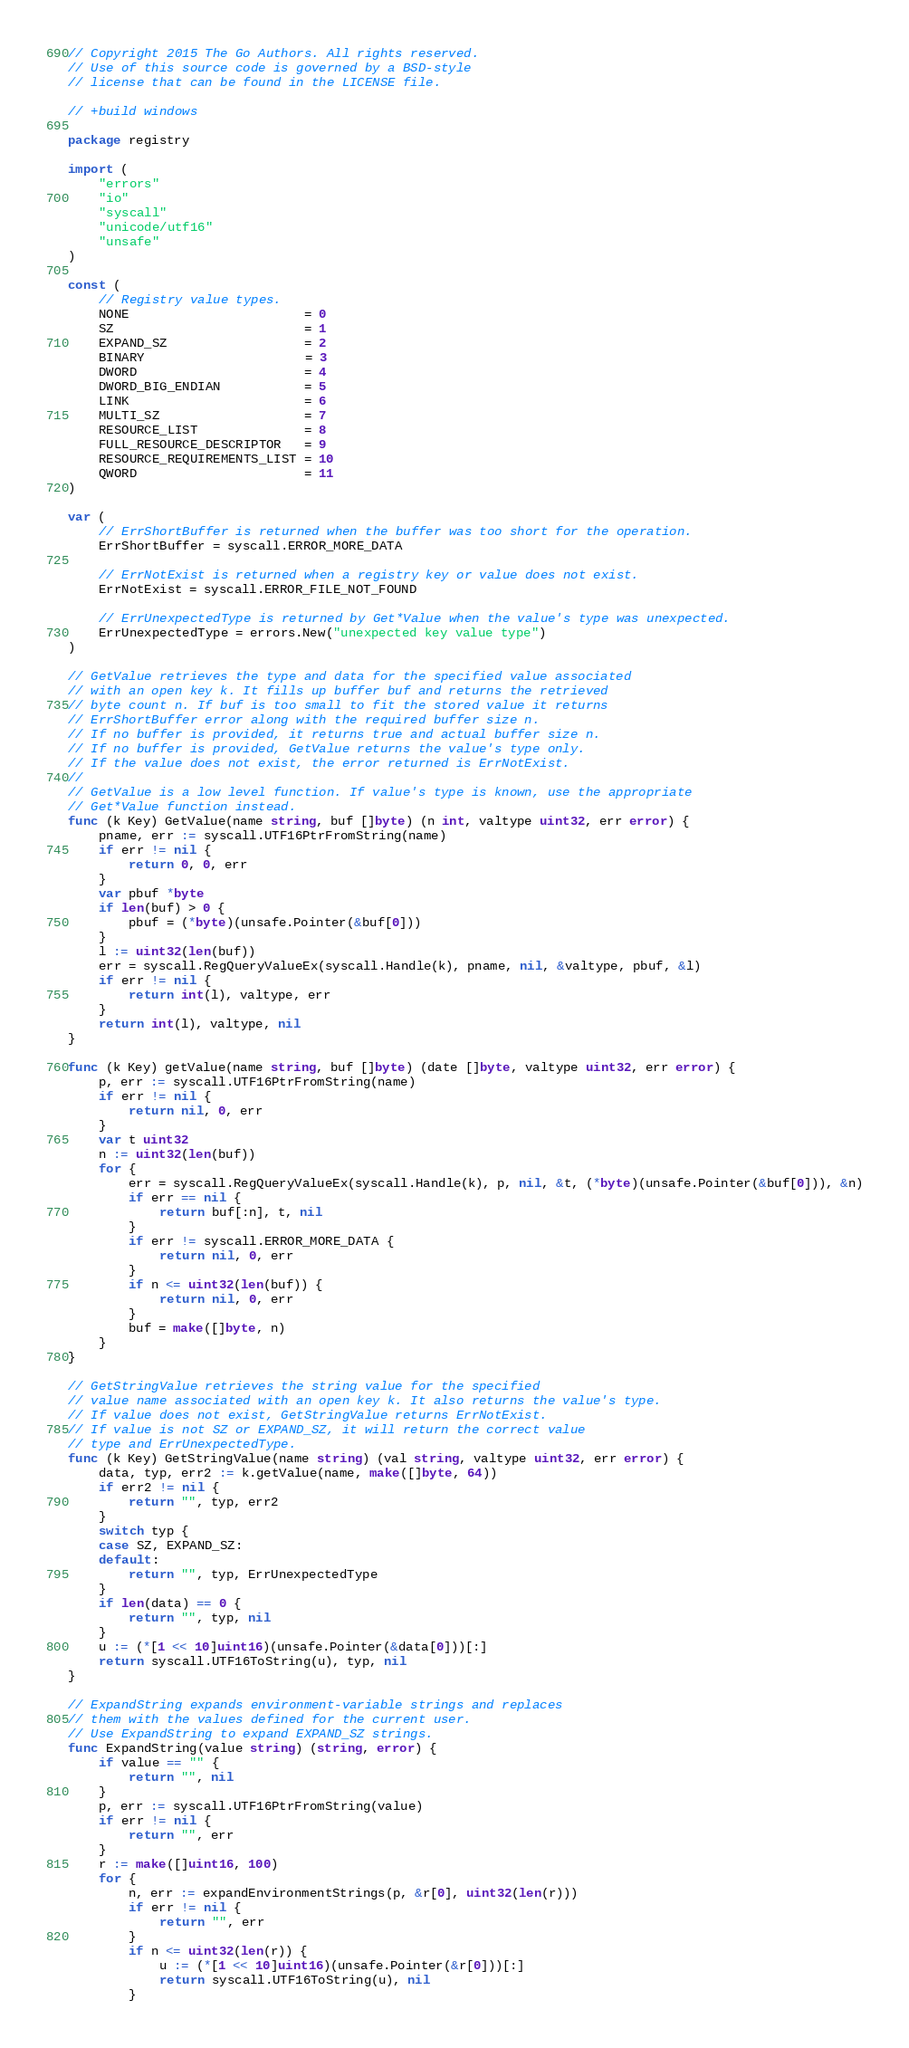<code> <loc_0><loc_0><loc_500><loc_500><_Go_>// Copyright 2015 The Go Authors. All rights reserved.
// Use of this source code is governed by a BSD-style
// license that can be found in the LICENSE file.

// +build windows

package registry

import (
	"errors"
	"io"
	"syscall"
	"unicode/utf16"
	"unsafe"
)

const (
	// Registry value types.
	NONE                       = 0
	SZ                         = 1
	EXPAND_SZ                  = 2
	BINARY                     = 3
	DWORD                      = 4
	DWORD_BIG_ENDIAN           = 5
	LINK                       = 6
	MULTI_SZ                   = 7
	RESOURCE_LIST              = 8
	FULL_RESOURCE_DESCRIPTOR   = 9
	RESOURCE_REQUIREMENTS_LIST = 10
	QWORD                      = 11
)

var (
	// ErrShortBuffer is returned when the buffer was too short for the operation.
	ErrShortBuffer = syscall.ERROR_MORE_DATA

	// ErrNotExist is returned when a registry key or value does not exist.
	ErrNotExist = syscall.ERROR_FILE_NOT_FOUND

	// ErrUnexpectedType is returned by Get*Value when the value's type was unexpected.
	ErrUnexpectedType = errors.New("unexpected key value type")
)

// GetValue retrieves the type and data for the specified value associated
// with an open key k. It fills up buffer buf and returns the retrieved
// byte count n. If buf is too small to fit the stored value it returns
// ErrShortBuffer error along with the required buffer size n.
// If no buffer is provided, it returns true and actual buffer size n.
// If no buffer is provided, GetValue returns the value's type only.
// If the value does not exist, the error returned is ErrNotExist.
//
// GetValue is a low level function. If value's type is known, use the appropriate
// Get*Value function instead.
func (k Key) GetValue(name string, buf []byte) (n int, valtype uint32, err error) {
	pname, err := syscall.UTF16PtrFromString(name)
	if err != nil {
		return 0, 0, err
	}
	var pbuf *byte
	if len(buf) > 0 {
		pbuf = (*byte)(unsafe.Pointer(&buf[0]))
	}
	l := uint32(len(buf))
	err = syscall.RegQueryValueEx(syscall.Handle(k), pname, nil, &valtype, pbuf, &l)
	if err != nil {
		return int(l), valtype, err
	}
	return int(l), valtype, nil
}

func (k Key) getValue(name string, buf []byte) (date []byte, valtype uint32, err error) {
	p, err := syscall.UTF16PtrFromString(name)
	if err != nil {
		return nil, 0, err
	}
	var t uint32
	n := uint32(len(buf))
	for {
		err = syscall.RegQueryValueEx(syscall.Handle(k), p, nil, &t, (*byte)(unsafe.Pointer(&buf[0])), &n)
		if err == nil {
			return buf[:n], t, nil
		}
		if err != syscall.ERROR_MORE_DATA {
			return nil, 0, err
		}
		if n <= uint32(len(buf)) {
			return nil, 0, err
		}
		buf = make([]byte, n)
	}
}

// GetStringValue retrieves the string value for the specified
// value name associated with an open key k. It also returns the value's type.
// If value does not exist, GetStringValue returns ErrNotExist.
// If value is not SZ or EXPAND_SZ, it will return the correct value
// type and ErrUnexpectedType.
func (k Key) GetStringValue(name string) (val string, valtype uint32, err error) {
	data, typ, err2 := k.getValue(name, make([]byte, 64))
	if err2 != nil {
		return "", typ, err2
	}
	switch typ {
	case SZ, EXPAND_SZ:
	default:
		return "", typ, ErrUnexpectedType
	}
	if len(data) == 0 {
		return "", typ, nil
	}
	u := (*[1 << 10]uint16)(unsafe.Pointer(&data[0]))[:]
	return syscall.UTF16ToString(u), typ, nil
}

// ExpandString expands environment-variable strings and replaces
// them with the values defined for the current user.
// Use ExpandString to expand EXPAND_SZ strings.
func ExpandString(value string) (string, error) {
	if value == "" {
		return "", nil
	}
	p, err := syscall.UTF16PtrFromString(value)
	if err != nil {
		return "", err
	}
	r := make([]uint16, 100)
	for {
		n, err := expandEnvironmentStrings(p, &r[0], uint32(len(r)))
		if err != nil {
			return "", err
		}
		if n <= uint32(len(r)) {
			u := (*[1 << 10]uint16)(unsafe.Pointer(&r[0]))[:]
			return syscall.UTF16ToString(u), nil
		}</code> 